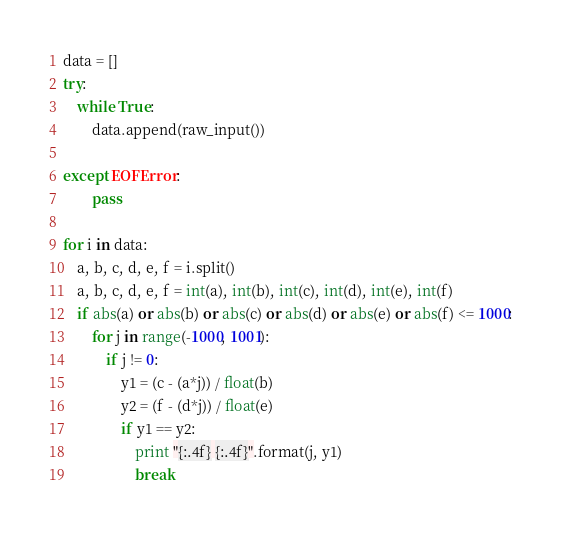Convert code to text. <code><loc_0><loc_0><loc_500><loc_500><_Python_>data = []
try:
    while True:
        data.append(raw_input())

except EOFError:
        pass

for i in data:
    a, b, c, d, e, f = i.split()
    a, b, c, d, e, f = int(a), int(b), int(c), int(d), int(e), int(f)
    if abs(a) or abs(b) or abs(c) or abs(d) or abs(e) or abs(f) <= 1000:
        for j in range(-1000, 1001):
            if j != 0:
                y1 = (c - (a*j)) / float(b)
                y2 = (f - (d*j)) / float(e)
                if y1 == y2: 
                    print "{:.4f} {:.4f}".format(j, y1) 
                    break</code> 